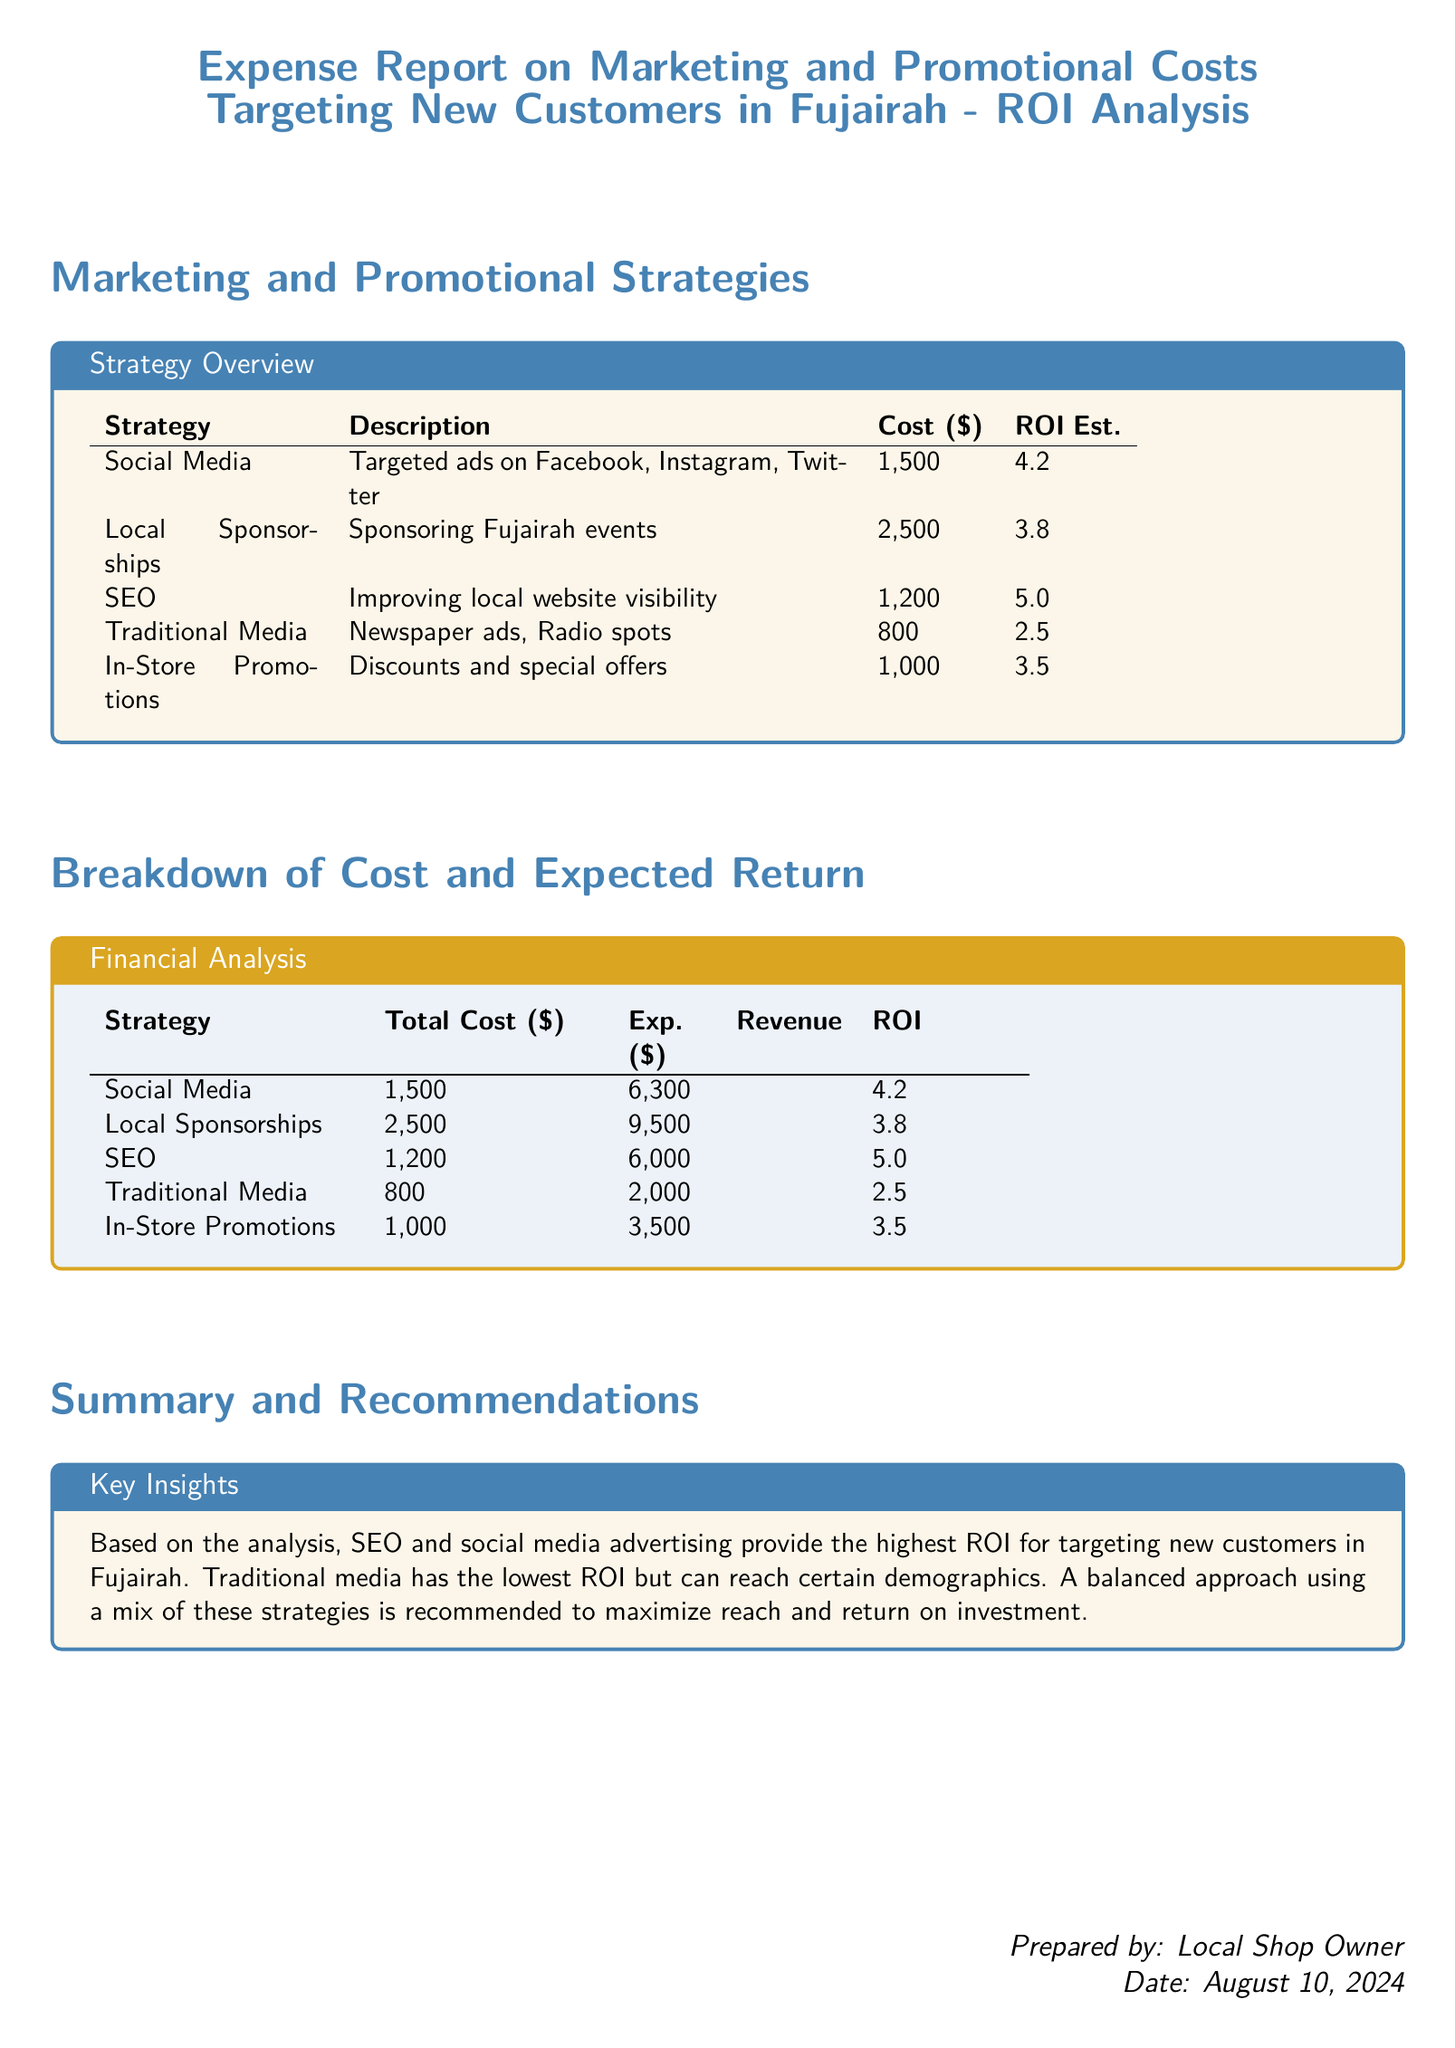What is the total cost of the SEO strategy? The total cost for the SEO strategy listed in the document is $1,200.
Answer: $1,200 What is the ROI for traditional media? The document states that the ROI for traditional media is 2.5.
Answer: 2.5 Which strategy has the highest expected revenue? Based on the financial analysis, social media has the highest expected revenue of $6,300.
Answer: $6,300 What is the total cost for local sponsorships? The document indicates that the total cost for local sponsorships is $2,500.
Answer: $2,500 Which promotional strategy offers the best ROI? The analysis shows that SEO provides the best ROI at 5.0.
Answer: 5.0 What is the primary recommendation from the summary? The summary recommends a balanced approach using a mix of strategies to maximize ROI.
Answer: A balanced approach What is the expected revenue for in-store promotions? According to the report, the expected revenue for in-store promotions is $3,500.
Answer: $3,500 What document type is this? This document is an expense report.
Answer: Expense report Which two strategies have their costs exceed $2,000? The strategies exceeding $2,000 in cost are local sponsorships and social media.
Answer: Local sponsorships and social media 